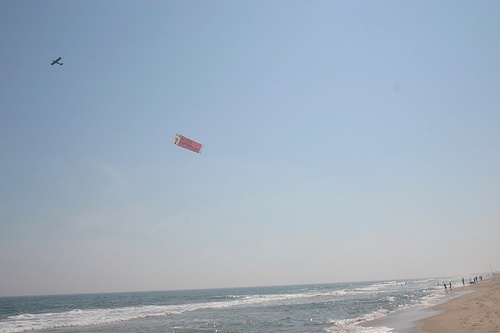Describe the objects in this image and their specific colors. I can see kite in gray and darkgray tones, airplane in gray, blue, and darkblue tones, people in gray tones, people in darkgray and gray tones, and people in gray, darkgray, and black tones in this image. 